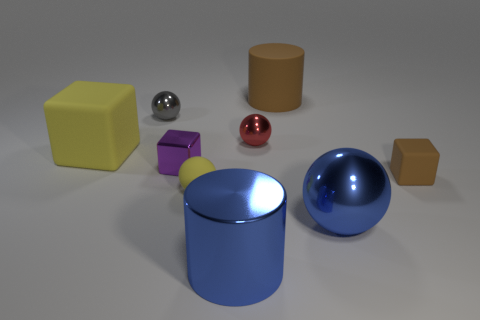Add 1 large red cylinders. How many objects exist? 10 Subtract all cylinders. How many objects are left? 7 Add 9 tiny blue spheres. How many tiny blue spheres exist? 9 Subtract 1 red balls. How many objects are left? 8 Subtract all brown cylinders. Subtract all large metal things. How many objects are left? 6 Add 2 small red shiny spheres. How many small red shiny spheres are left? 3 